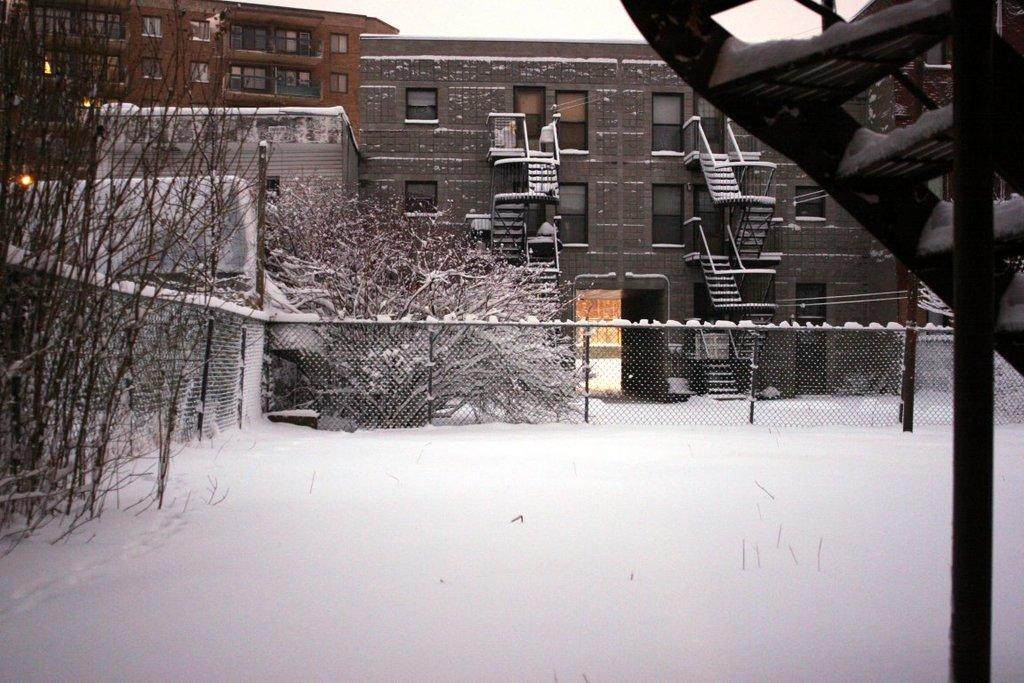What is the condition of the land in the image? The land in the image is covered with snow. What can be seen in the background of the image? There is fencing, buildings, and trees in the background of the image. How does the earthquake affect the vase in the image? There is no vase or earthquake present in the image. 